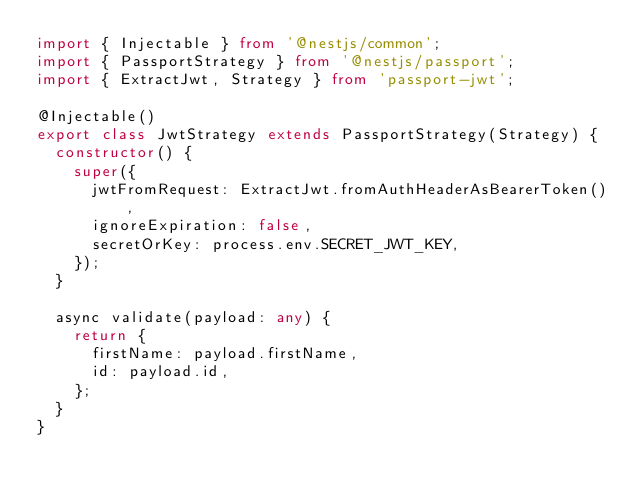Convert code to text. <code><loc_0><loc_0><loc_500><loc_500><_TypeScript_>import { Injectable } from '@nestjs/common';
import { PassportStrategy } from '@nestjs/passport';
import { ExtractJwt, Strategy } from 'passport-jwt';

@Injectable()
export class JwtStrategy extends PassportStrategy(Strategy) {
  constructor() {
    super({
      jwtFromRequest: ExtractJwt.fromAuthHeaderAsBearerToken(),
      ignoreExpiration: false,
      secretOrKey: process.env.SECRET_JWT_KEY,
    });
  }

  async validate(payload: any) {
    return {
      firstName: payload.firstName,
      id: payload.id,
    };
  }
}
</code> 